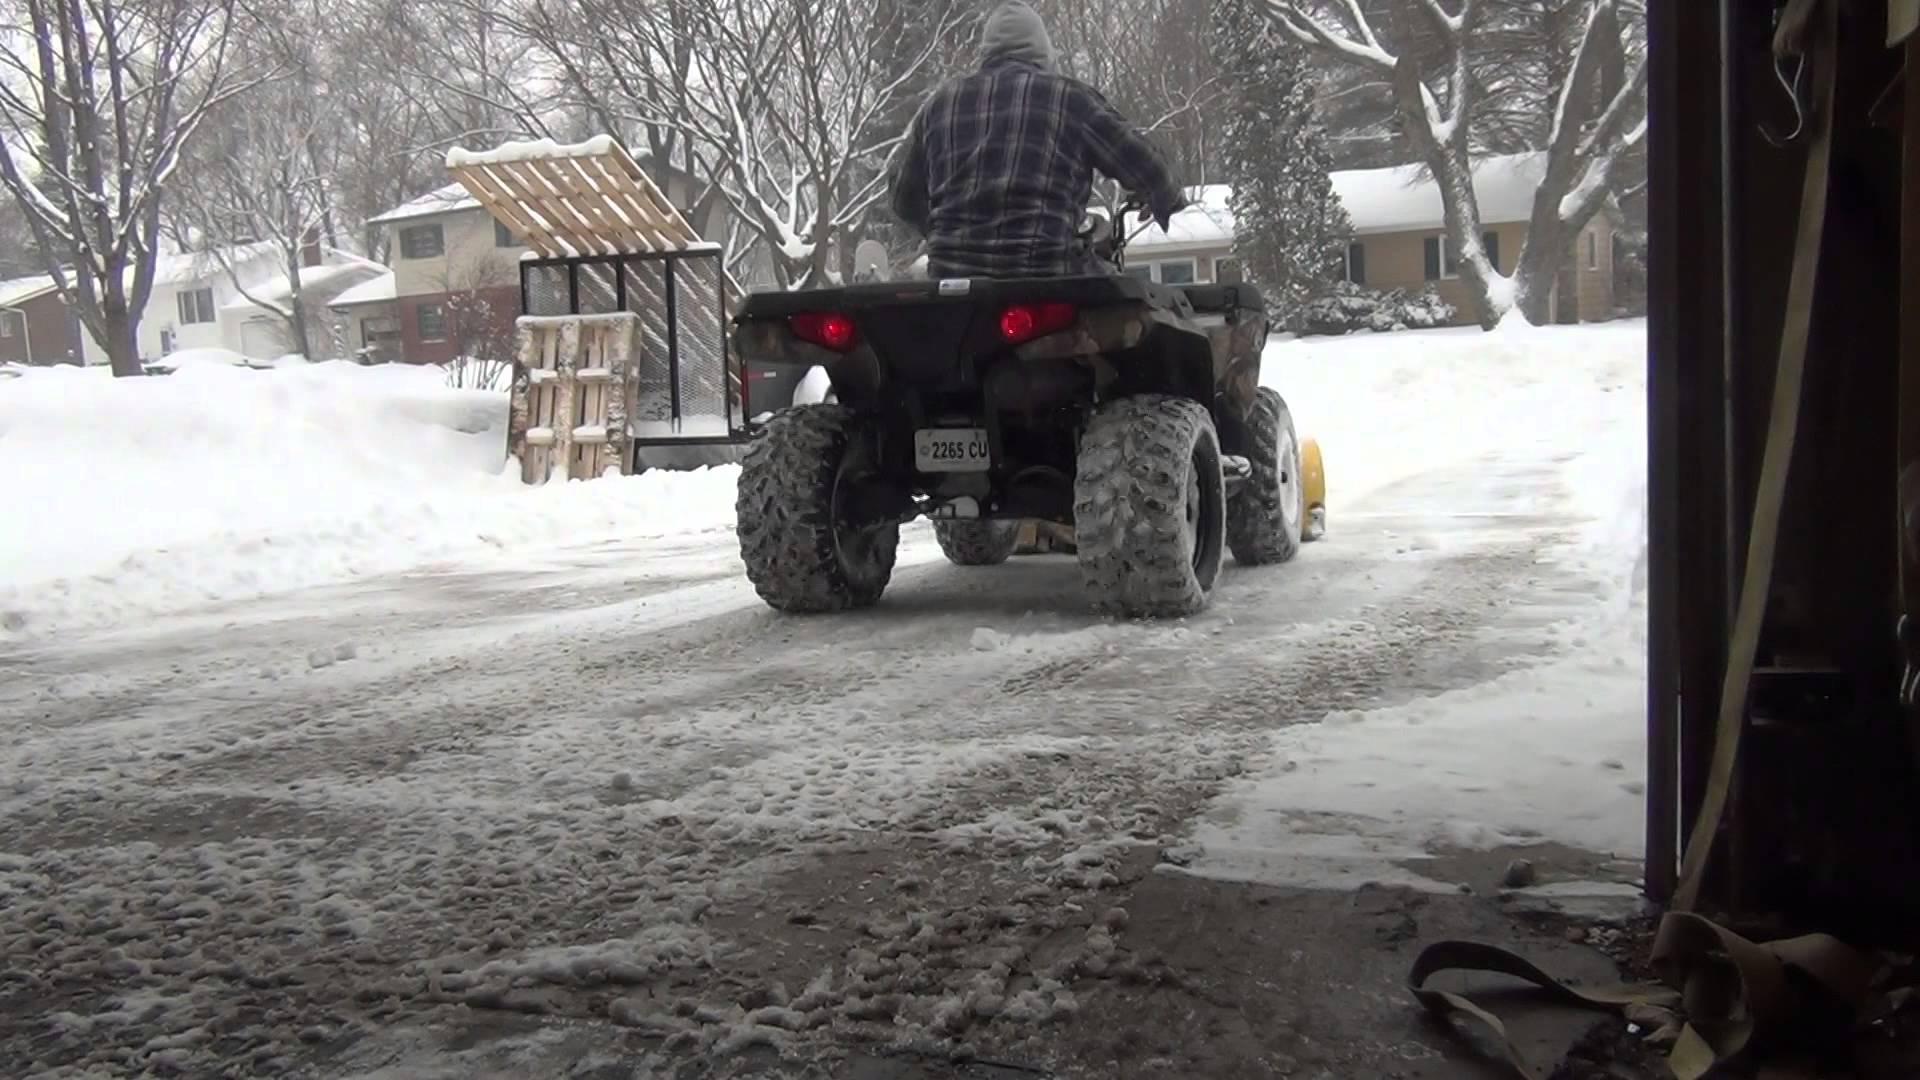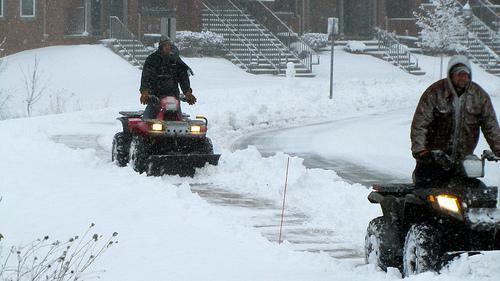The first image is the image on the left, the second image is the image on the right. Evaluate the accuracy of this statement regarding the images: "All four wheelers are in snowy areas and have drivers.". Is it true? Answer yes or no. Yes. 